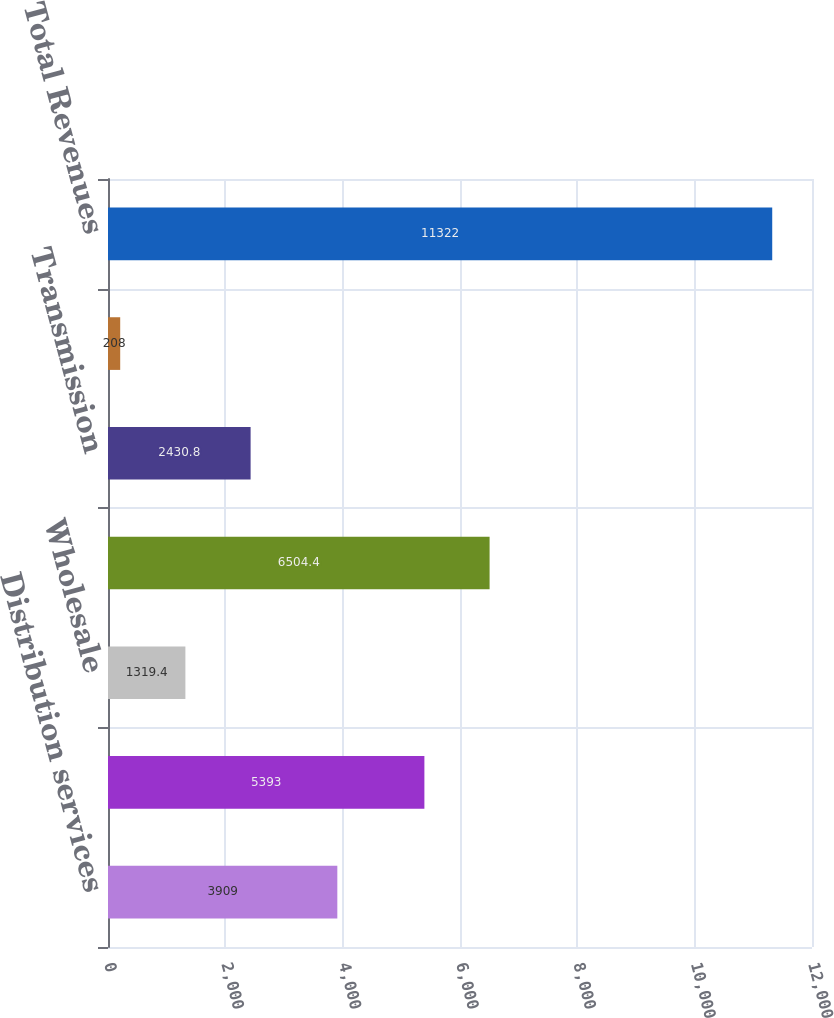Convert chart. <chart><loc_0><loc_0><loc_500><loc_500><bar_chart><fcel>Distribution services<fcel>Retail<fcel>Wholesale<fcel>Total generation sales<fcel>Transmission<fcel>Other<fcel>Total Revenues<nl><fcel>3909<fcel>5393<fcel>1319.4<fcel>6504.4<fcel>2430.8<fcel>208<fcel>11322<nl></chart> 